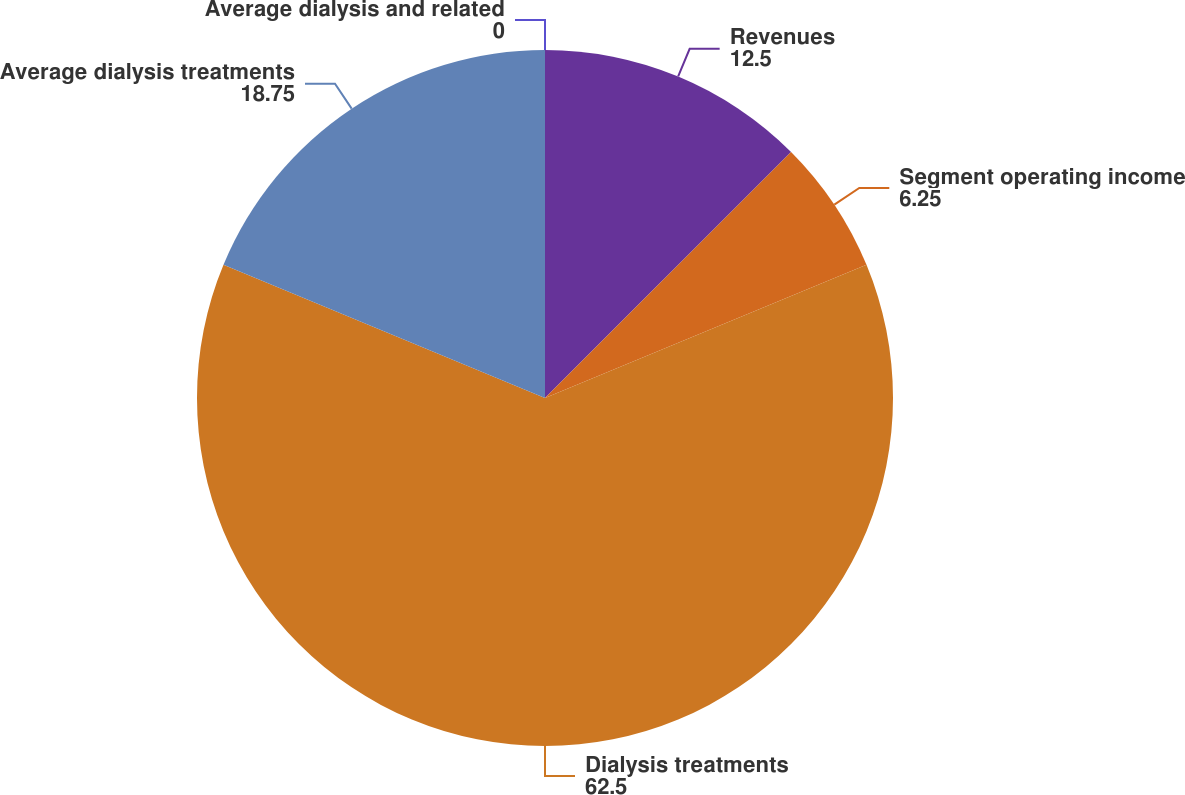Convert chart. <chart><loc_0><loc_0><loc_500><loc_500><pie_chart><fcel>Revenues<fcel>Segment operating income<fcel>Dialysis treatments<fcel>Average dialysis treatments<fcel>Average dialysis and related<nl><fcel>12.5%<fcel>6.25%<fcel>62.5%<fcel>18.75%<fcel>0.0%<nl></chart> 